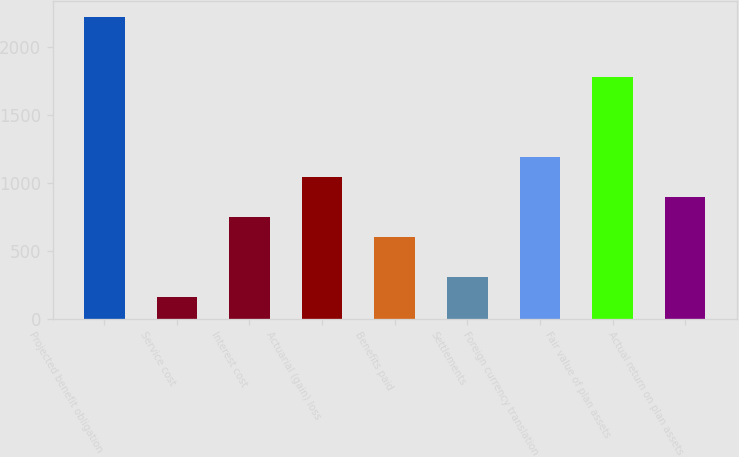Convert chart. <chart><loc_0><loc_0><loc_500><loc_500><bar_chart><fcel>Projected benefit obligation<fcel>Service cost<fcel>Interest cost<fcel>Actuarial (gain) loss<fcel>Benefits paid<fcel>Settlements<fcel>Foreign currency translation<fcel>Fair value of plan assets<fcel>Actual return on plan assets<nl><fcel>2228<fcel>158.8<fcel>750<fcel>1045.6<fcel>602.2<fcel>306.6<fcel>1193.4<fcel>1784.6<fcel>897.8<nl></chart> 